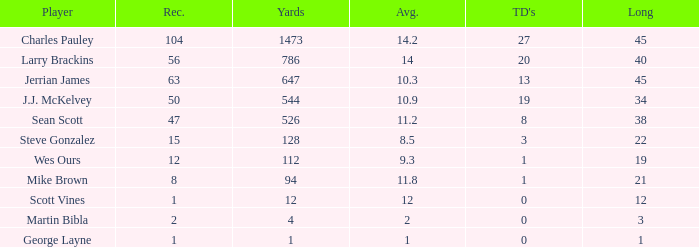How many receptions for players with over 647 yards and an under 14 yard average? None. 